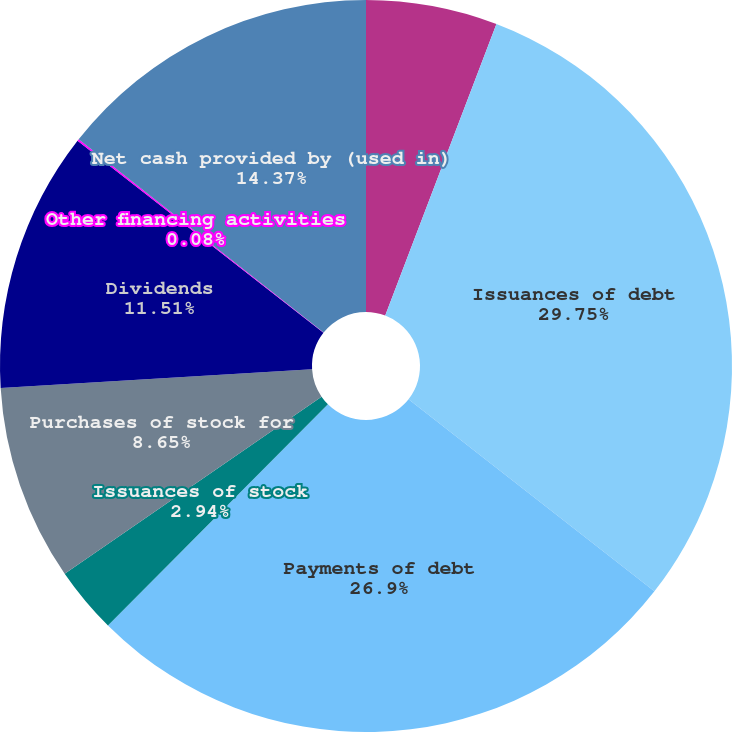Convert chart to OTSL. <chart><loc_0><loc_0><loc_500><loc_500><pie_chart><fcel>Year Ended December 31<fcel>Issuances of debt<fcel>Payments of debt<fcel>Issuances of stock<fcel>Purchases of stock for<fcel>Dividends<fcel>Other financing activities<fcel>Net cash provided by (used in)<nl><fcel>5.8%<fcel>29.76%<fcel>26.9%<fcel>2.94%<fcel>8.65%<fcel>11.51%<fcel>0.08%<fcel>14.37%<nl></chart> 